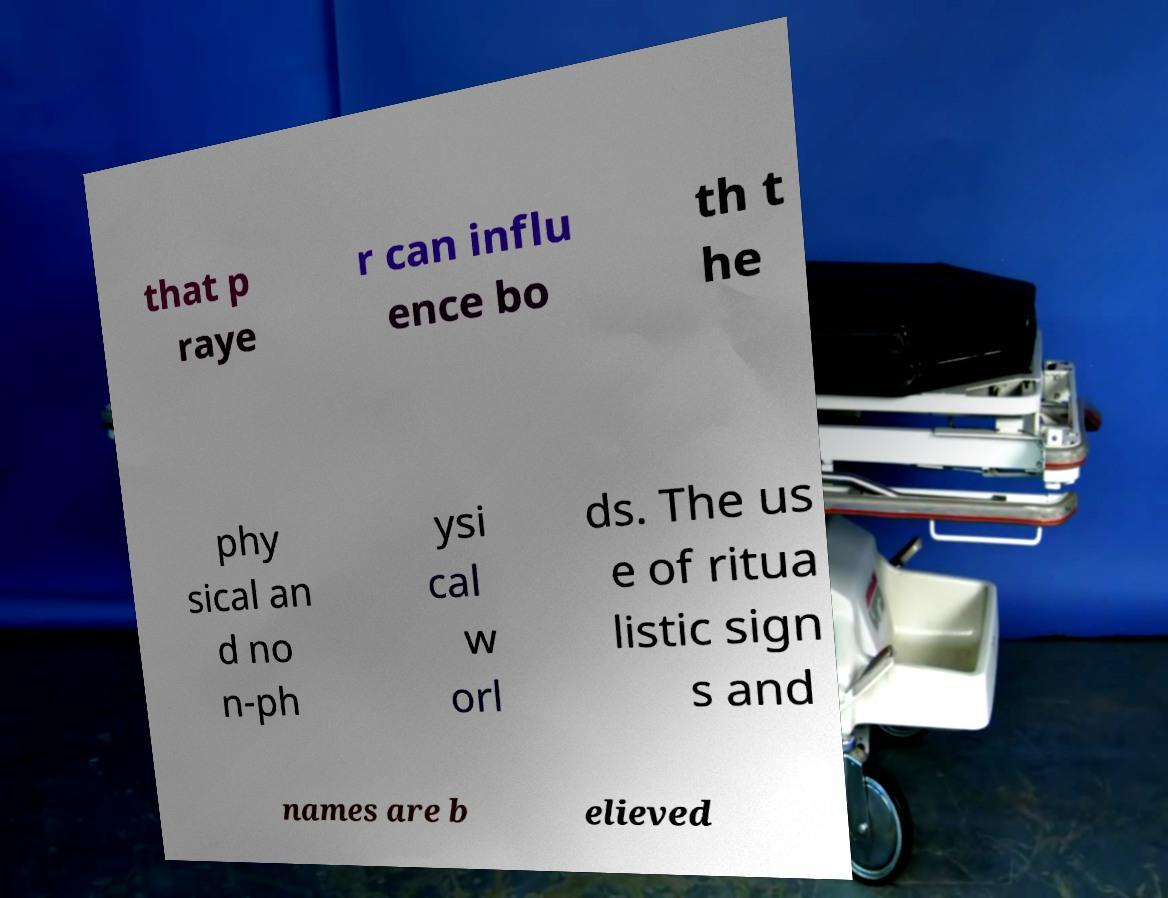Please read and relay the text visible in this image. What does it say? that p raye r can influ ence bo th t he phy sical an d no n-ph ysi cal w orl ds. The us e of ritua listic sign s and names are b elieved 